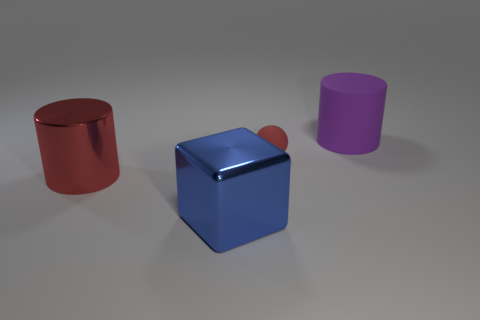There is a cylinder that is on the left side of the thing in front of the large cylinder left of the tiny red object; what is it made of? metal 